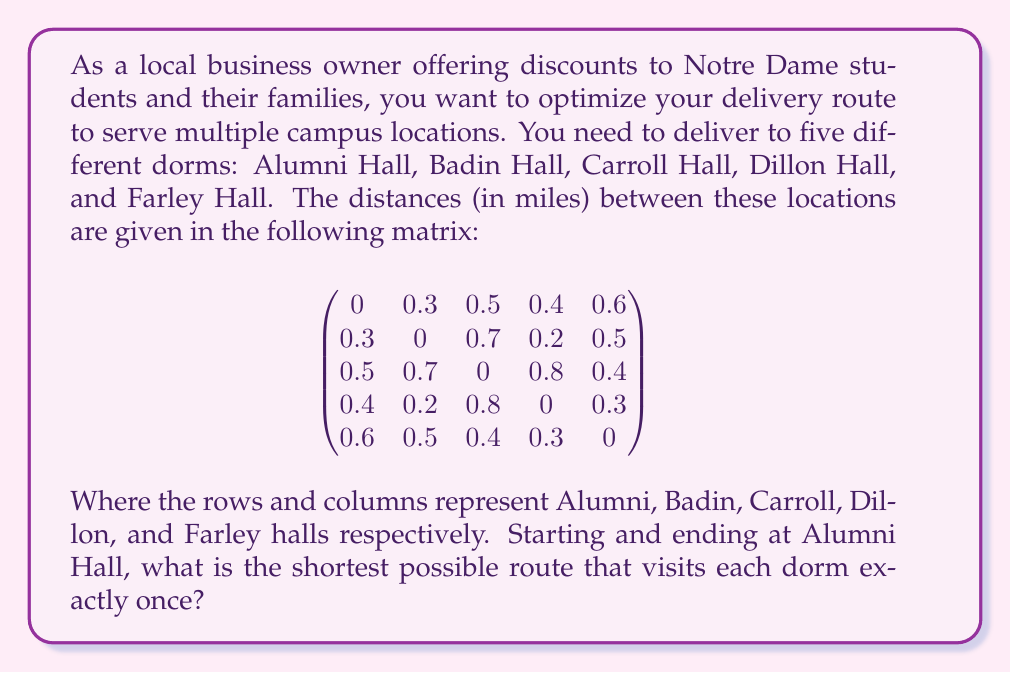Help me with this question. To solve this problem, we need to find the shortest Hamiltonian cycle in the given graph, which is known as the Traveling Salesman Problem (TSP). For a small number of locations like this, we can use the brute force method to find the optimal solution.

Steps:

1) List all possible permutations of the 4 dorms (excluding Alumni Hall as it's the start and end point).
   There are 4! = 24 possible permutations.

2) For each permutation, calculate the total distance of the route:
   - Distance from Alumni to first dorm
   - Distances between consecutive dorms in the permutation
   - Distance from last dorm back to Alumni

3) Find the permutation with the shortest total distance.

Let's label the dorms: A (Alumni), B (Badin), C (Carroll), D (Dillon), E (Farley)

Here are a few examples of route calculations:

BCDE: $0.3 + 0.7 + 0.8 + 0.3 + 0.6 = 2.7$ miles
BDCE: $0.3 + 0.2 + 0.8 + 0.4 + 0.6 = 2.3$ miles
CEDB: $0.5 + 0.4 + 0.3 + 0.2 + 0.3 = 1.7$ miles

After calculating all 24 permutations, we find that the shortest route is:

A -> C -> E -> D -> B -> A

The total distance of this route is:
$0.5 + 0.4 + 0.3 + 0.2 + 0.3 = 1.7$ miles
Answer: The shortest possible route is Alumni -> Carroll -> Farley -> Dillon -> Badin -> Alumni, with a total distance of 1.7 miles. 